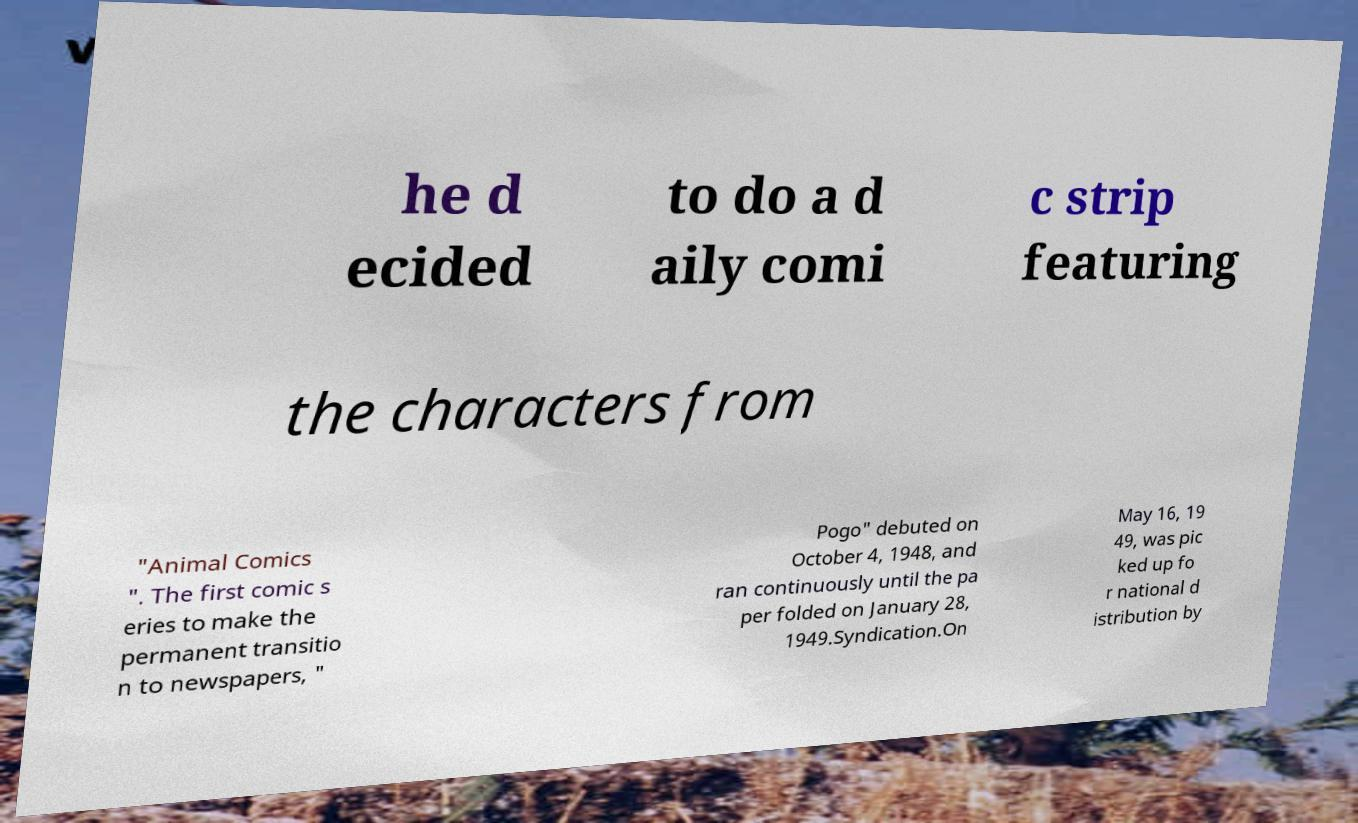Can you read and provide the text displayed in the image?This photo seems to have some interesting text. Can you extract and type it out for me? he d ecided to do a d aily comi c strip featuring the characters from "Animal Comics ". The first comic s eries to make the permanent transitio n to newspapers, " Pogo" debuted on October 4, 1948, and ran continuously until the pa per folded on January 28, 1949.Syndication.On May 16, 19 49, was pic ked up fo r national d istribution by 